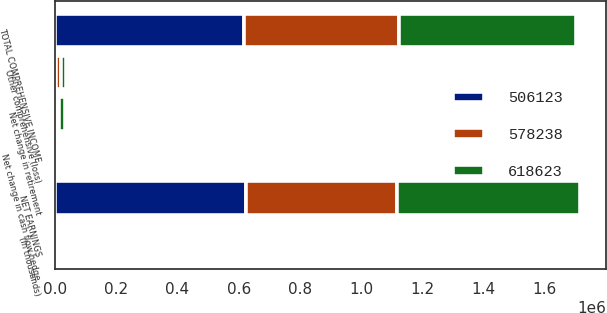Convert chart to OTSL. <chart><loc_0><loc_0><loc_500><loc_500><stacked_bar_chart><ecel><fcel>(In thousands)<fcel>NET EARNINGS<fcel>Net change in retirement<fcel>Net change in cash flow hedge<fcel>Other comprehensive (loss)<fcel>TOTAL COMPREHENSIVE INCOME<nl><fcel>506123<fcel>2016<fcel>623428<fcel>2750<fcel>7555<fcel>4805<fcel>618623<nl><fcel>618623<fcel>2015<fcel>597358<fcel>20505<fcel>1385<fcel>19120<fcel>578238<nl><fcel>578238<fcel>2014<fcel>492586<fcel>10764<fcel>2773<fcel>13537<fcel>506123<nl></chart> 